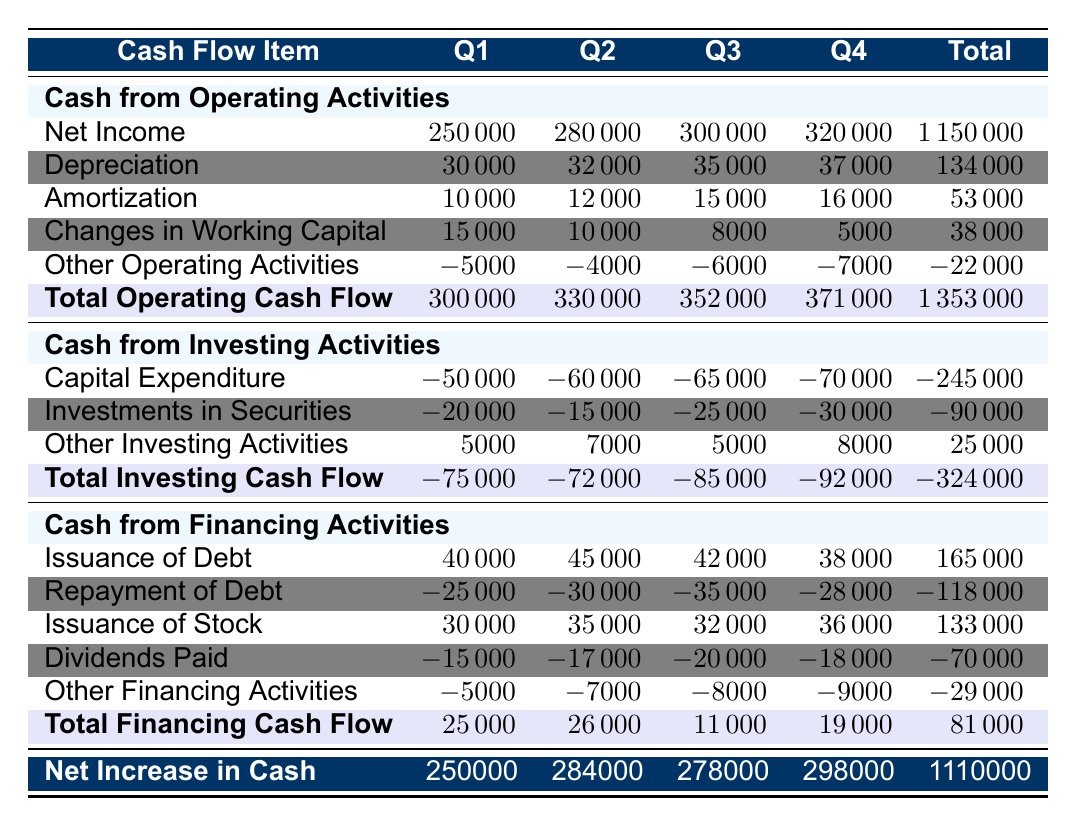What is the total cash flow from operating activities for Q3? The table shows that the total cash flow from operating activities for Q3 is listed directly under that row, which indicates it is 352000.
Answer: 352000 What was the capital expenditure for Q2? From the table, we can see that the capital expenditure for Q2 is directly stated as -60000.
Answer: -60000 Is the total cash flow from investing activities positive for any quarter? By examining each quarterly total for cash from investing activities, we see that all totals are negative: -75000, -72000, -85000, and -92000. Thus, the answer is no.
Answer: No What is the total net increase in cash for the year? The table summarizes the net increase in cash at the end under the "Net Increase in Cash" row, showing the yearly total as 1116000.
Answer: 1116000 What is the average cash flow from financing activities over the four quarters? First, we need to sum the financing activities for the quarters: 25000 + 26000 + 11000 + 19000 = 81000. Then, we divide this sum by the number of quarters (4): 81000 / 4 = 20250.
Answer: 20250 Which quarter had the highest net income? To find the highest net income, we compare the net income figures listed under cash from operating activities across all quarters: 250000, 280000, 300000, and 320000. The highest is 320000 in Q4.
Answer: Q4 How much did ACME Manufacturing Co. pay in dividends during Q1? The table indicates that the dividends paid for Q1 is listed as -15000 under cash from financing activities.
Answer: -15000 Did the cash from financing activities increase across the quarters? We check the total cash flow from financing activities for each quarter: 25000, 26000, 11000, 19000. The values show fluctuations, with a decrease from Q2 to Q3 and again to Q4, so the answer is no.
Answer: No What was the total cash outflow from investments in securities for the year? We sum the investments in securities for each quarter: -20000, -15000, -25000, and -30000. The total cash outflow from investments in securities for the year is -90000.
Answer: -90000 